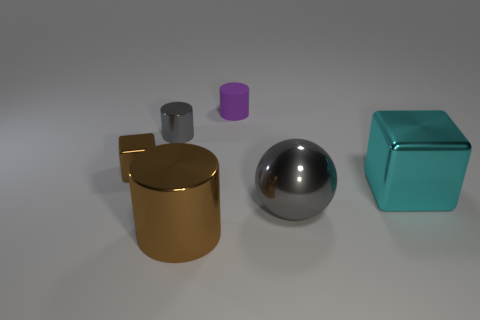Subtract all shiny cylinders. How many cylinders are left? 1 Add 3 large gray shiny things. How many objects exist? 9 Subtract all spheres. How many objects are left? 5 Add 2 shiny things. How many shiny things exist? 7 Subtract 0 red spheres. How many objects are left? 6 Subtract all big purple metallic objects. Subtract all large objects. How many objects are left? 3 Add 6 big cyan objects. How many big cyan objects are left? 7 